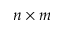<formula> <loc_0><loc_0><loc_500><loc_500>n \times m</formula> 